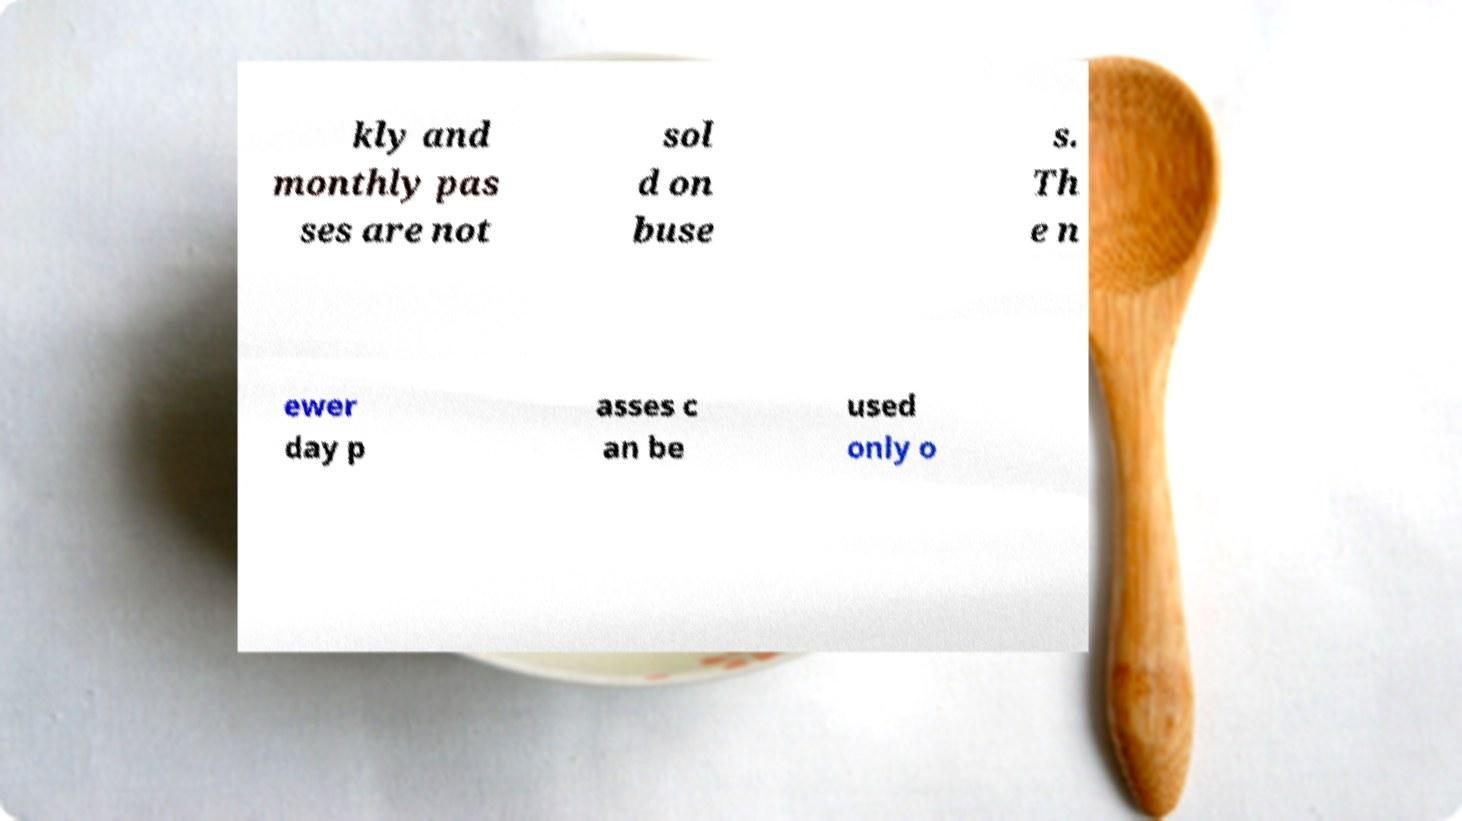For documentation purposes, I need the text within this image transcribed. Could you provide that? kly and monthly pas ses are not sol d on buse s. Th e n ewer day p asses c an be used only o 